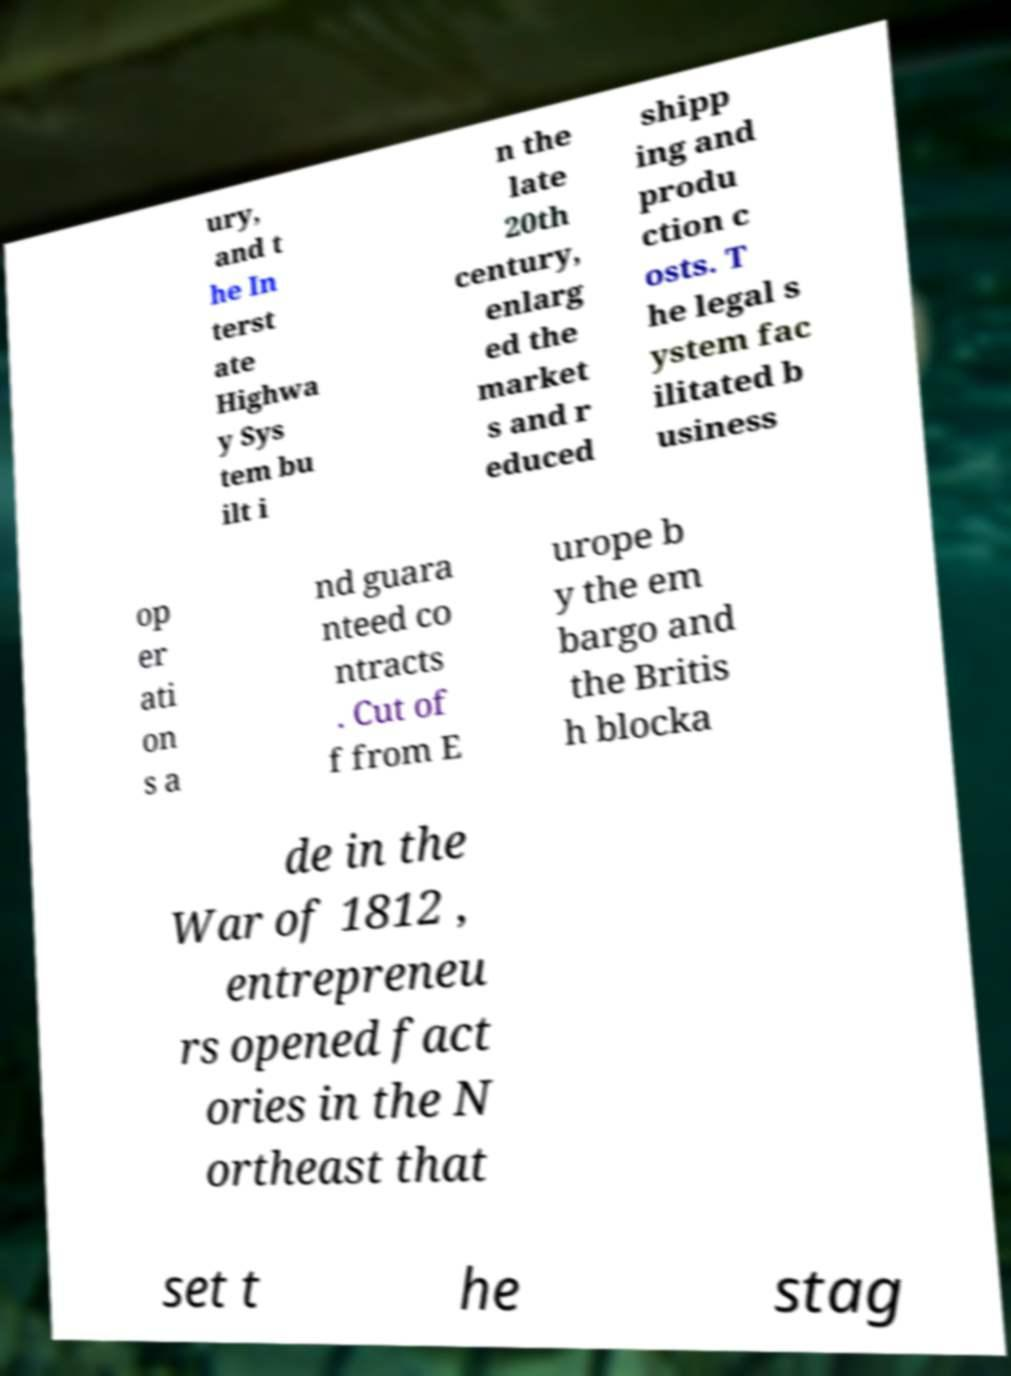Please identify and transcribe the text found in this image. ury, and t he In terst ate Highwa y Sys tem bu ilt i n the late 20th century, enlarg ed the market s and r educed shipp ing and produ ction c osts. T he legal s ystem fac ilitated b usiness op er ati on s a nd guara nteed co ntracts . Cut of f from E urope b y the em bargo and the Britis h blocka de in the War of 1812 , entrepreneu rs opened fact ories in the N ortheast that set t he stag 